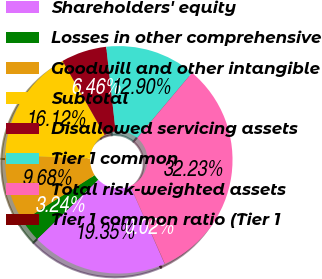Convert chart to OTSL. <chart><loc_0><loc_0><loc_500><loc_500><pie_chart><fcel>Shareholders' equity<fcel>Losses in other comprehensive<fcel>Goodwill and other intangible<fcel>Subtotal<fcel>Disallowed servicing assets<fcel>Tier 1 common<fcel>Total risk-weighted assets<fcel>Tier 1 common ratio (Tier 1<nl><fcel>19.35%<fcel>3.24%<fcel>9.68%<fcel>16.12%<fcel>6.46%<fcel>12.9%<fcel>32.23%<fcel>0.02%<nl></chart> 